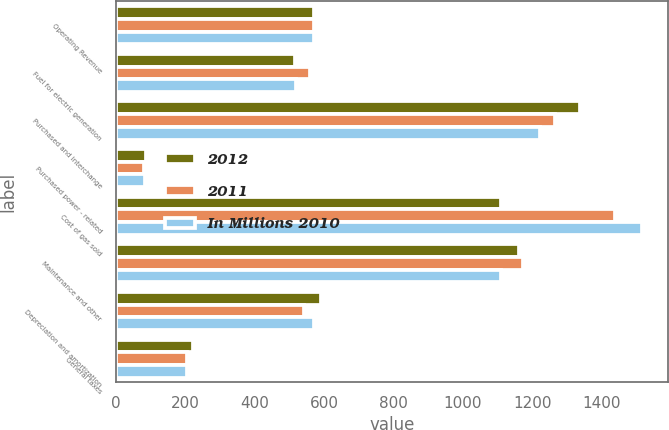Convert chart. <chart><loc_0><loc_0><loc_500><loc_500><stacked_bar_chart><ecel><fcel>Operating Revenue<fcel>Fuel for electric generation<fcel>Purchased and interchange<fcel>Purchased power - related<fcel>Cost of gas sold<fcel>Maintenance and other<fcel>Depreciation and amortization<fcel>General taxes<nl><fcel>2012<fcel>572<fcel>517<fcel>1339<fcel>86<fcel>1110<fcel>1162<fcel>592<fcel>223<nl><fcel>2011<fcel>572<fcel>559<fcel>1267<fcel>81<fcel>1438<fcel>1175<fcel>542<fcel>206<nl><fcel>In Millions 2010<fcel>572<fcel>520<fcel>1224<fcel>84<fcel>1516<fcel>1109<fcel>572<fcel>205<nl></chart> 